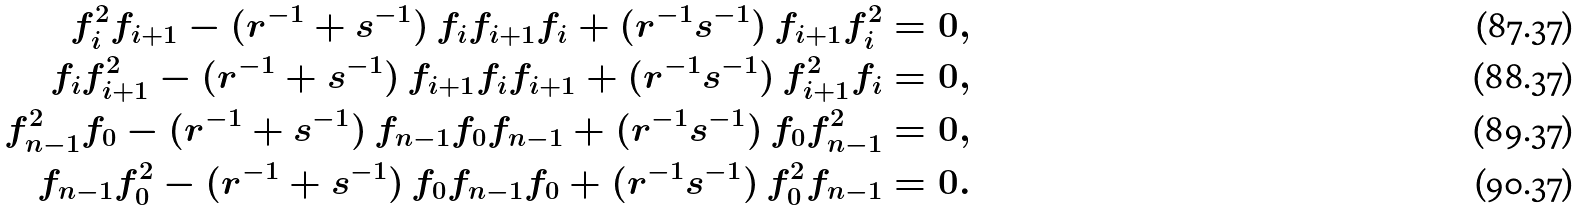<formula> <loc_0><loc_0><loc_500><loc_500>f _ { i } ^ { 2 } f _ { i + 1 } - ( r ^ { - 1 } + s ^ { - 1 } ) \, f _ { i } f _ { i + 1 } f _ { i } + ( r ^ { - 1 } s ^ { - 1 } ) \, f _ { i + 1 } f _ { i } ^ { 2 } = 0 , \\ f _ { i } f _ { i + 1 } ^ { 2 } - ( r ^ { - 1 } + s ^ { - 1 } ) \, f _ { i + 1 } f _ { i } f _ { i + 1 } + ( r ^ { - 1 } s ^ { - 1 } ) \, f _ { i + 1 } ^ { 2 } f _ { i } = 0 , \\ f _ { n - 1 } ^ { 2 } f _ { 0 } - ( r ^ { - 1 } + s ^ { - 1 } ) \, f _ { n - 1 } f _ { 0 } f _ { n - 1 } + ( r ^ { - 1 } s ^ { - 1 } ) \, f _ { 0 } f _ { n - 1 } ^ { 2 } = 0 , \\ f _ { n - 1 } f _ { 0 } ^ { 2 } - ( r ^ { - 1 } + s ^ { - 1 } ) \, f _ { 0 } f _ { n - 1 } f _ { 0 } + ( r ^ { - 1 } s ^ { - 1 } ) \, f _ { 0 } ^ { 2 } f _ { n - 1 } = 0 .</formula> 